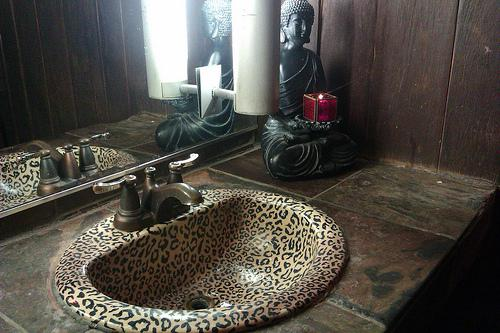Question: what is on right side?
Choices:
A. A stop sign.
B. A house.
C. A motorcycle.
D. A statue.
Answer with the letter. Answer: D Question: how many people are in picture?
Choices:
A. None.
B. Two.
C. Three.
D. Four.
Answer with the letter. Answer: A Question: who is in the picture?
Choices:
A. A guy surfing.
B. No one.
C. A woman holding ski poles.
D. A guy on his cellphone.
Answer with the letter. Answer: B 